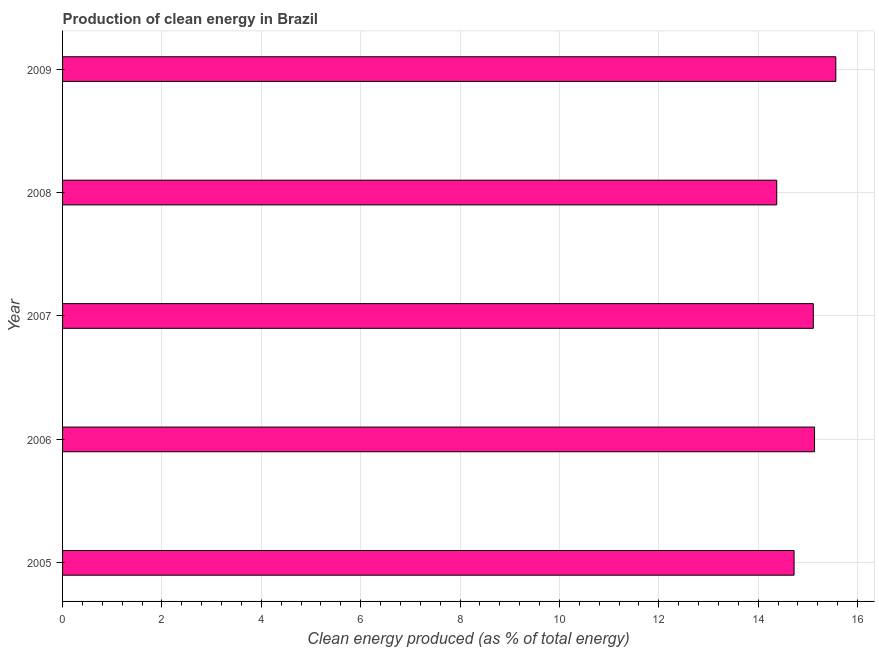Does the graph contain grids?
Provide a succinct answer. Yes. What is the title of the graph?
Your answer should be very brief. Production of clean energy in Brazil. What is the label or title of the X-axis?
Make the answer very short. Clean energy produced (as % of total energy). What is the production of clean energy in 2006?
Your response must be concise. 15.13. Across all years, what is the maximum production of clean energy?
Provide a succinct answer. 15.56. Across all years, what is the minimum production of clean energy?
Give a very brief answer. 14.37. In which year was the production of clean energy maximum?
Give a very brief answer. 2009. In which year was the production of clean energy minimum?
Offer a terse response. 2008. What is the sum of the production of clean energy?
Your answer should be very brief. 74.9. What is the difference between the production of clean energy in 2005 and 2006?
Offer a terse response. -0.41. What is the average production of clean energy per year?
Ensure brevity in your answer.  14.98. What is the median production of clean energy?
Offer a very short reply. 15.11. Do a majority of the years between 2007 and 2005 (inclusive) have production of clean energy greater than 4.8 %?
Ensure brevity in your answer.  Yes. What is the ratio of the production of clean energy in 2008 to that in 2009?
Your answer should be compact. 0.92. Is the production of clean energy in 2005 less than that in 2007?
Offer a terse response. Yes. What is the difference between the highest and the second highest production of clean energy?
Your answer should be compact. 0.43. What is the difference between the highest and the lowest production of clean energy?
Provide a short and direct response. 1.19. How many bars are there?
Provide a succinct answer. 5. Are all the bars in the graph horizontal?
Keep it short and to the point. Yes. How many years are there in the graph?
Give a very brief answer. 5. Are the values on the major ticks of X-axis written in scientific E-notation?
Make the answer very short. No. What is the Clean energy produced (as % of total energy) of 2005?
Offer a terse response. 14.72. What is the Clean energy produced (as % of total energy) of 2006?
Offer a terse response. 15.13. What is the Clean energy produced (as % of total energy) of 2007?
Keep it short and to the point. 15.11. What is the Clean energy produced (as % of total energy) of 2008?
Make the answer very short. 14.37. What is the Clean energy produced (as % of total energy) of 2009?
Offer a terse response. 15.56. What is the difference between the Clean energy produced (as % of total energy) in 2005 and 2006?
Your response must be concise. -0.41. What is the difference between the Clean energy produced (as % of total energy) in 2005 and 2007?
Your response must be concise. -0.39. What is the difference between the Clean energy produced (as % of total energy) in 2005 and 2008?
Your answer should be compact. 0.35. What is the difference between the Clean energy produced (as % of total energy) in 2005 and 2009?
Ensure brevity in your answer.  -0.84. What is the difference between the Clean energy produced (as % of total energy) in 2006 and 2007?
Give a very brief answer. 0.02. What is the difference between the Clean energy produced (as % of total energy) in 2006 and 2008?
Make the answer very short. 0.76. What is the difference between the Clean energy produced (as % of total energy) in 2006 and 2009?
Provide a succinct answer. -0.43. What is the difference between the Clean energy produced (as % of total energy) in 2007 and 2008?
Your answer should be compact. 0.74. What is the difference between the Clean energy produced (as % of total energy) in 2007 and 2009?
Provide a short and direct response. -0.45. What is the difference between the Clean energy produced (as % of total energy) in 2008 and 2009?
Give a very brief answer. -1.19. What is the ratio of the Clean energy produced (as % of total energy) in 2005 to that in 2007?
Keep it short and to the point. 0.97. What is the ratio of the Clean energy produced (as % of total energy) in 2005 to that in 2008?
Your answer should be very brief. 1.02. What is the ratio of the Clean energy produced (as % of total energy) in 2005 to that in 2009?
Provide a short and direct response. 0.95. What is the ratio of the Clean energy produced (as % of total energy) in 2006 to that in 2007?
Your answer should be very brief. 1. What is the ratio of the Clean energy produced (as % of total energy) in 2006 to that in 2008?
Keep it short and to the point. 1.05. What is the ratio of the Clean energy produced (as % of total energy) in 2006 to that in 2009?
Your answer should be compact. 0.97. What is the ratio of the Clean energy produced (as % of total energy) in 2007 to that in 2008?
Keep it short and to the point. 1.05. What is the ratio of the Clean energy produced (as % of total energy) in 2008 to that in 2009?
Your answer should be compact. 0.92. 